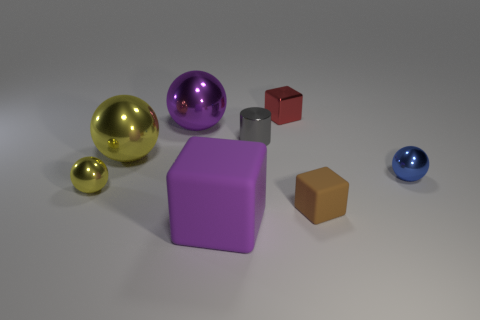The purple object that is the same shape as the tiny blue thing is what size?
Ensure brevity in your answer.  Large. Is there anything else that is the same size as the gray object?
Ensure brevity in your answer.  Yes. Is the brown object the same shape as the tiny blue metal thing?
Provide a short and direct response. No. Are there fewer purple cubes that are behind the metal cylinder than yellow shiny objects on the left side of the large yellow shiny thing?
Give a very brief answer. Yes. How many tiny gray metallic things are in front of the tiny rubber object?
Give a very brief answer. 0. There is a tiny thing on the left side of the large matte cube; is its shape the same as the yellow thing behind the small yellow metal ball?
Provide a succinct answer. Yes. How many other things are there of the same color as the cylinder?
Your answer should be very brief. 0. There is a tiny sphere that is left of the matte thing in front of the rubber block that is behind the big purple block; what is its material?
Offer a very short reply. Metal. There is a purple sphere behind the small sphere behind the tiny yellow ball; what is it made of?
Provide a succinct answer. Metal. Is the number of big purple blocks that are to the left of the large matte cube less than the number of large blue metal cylinders?
Offer a very short reply. No. 